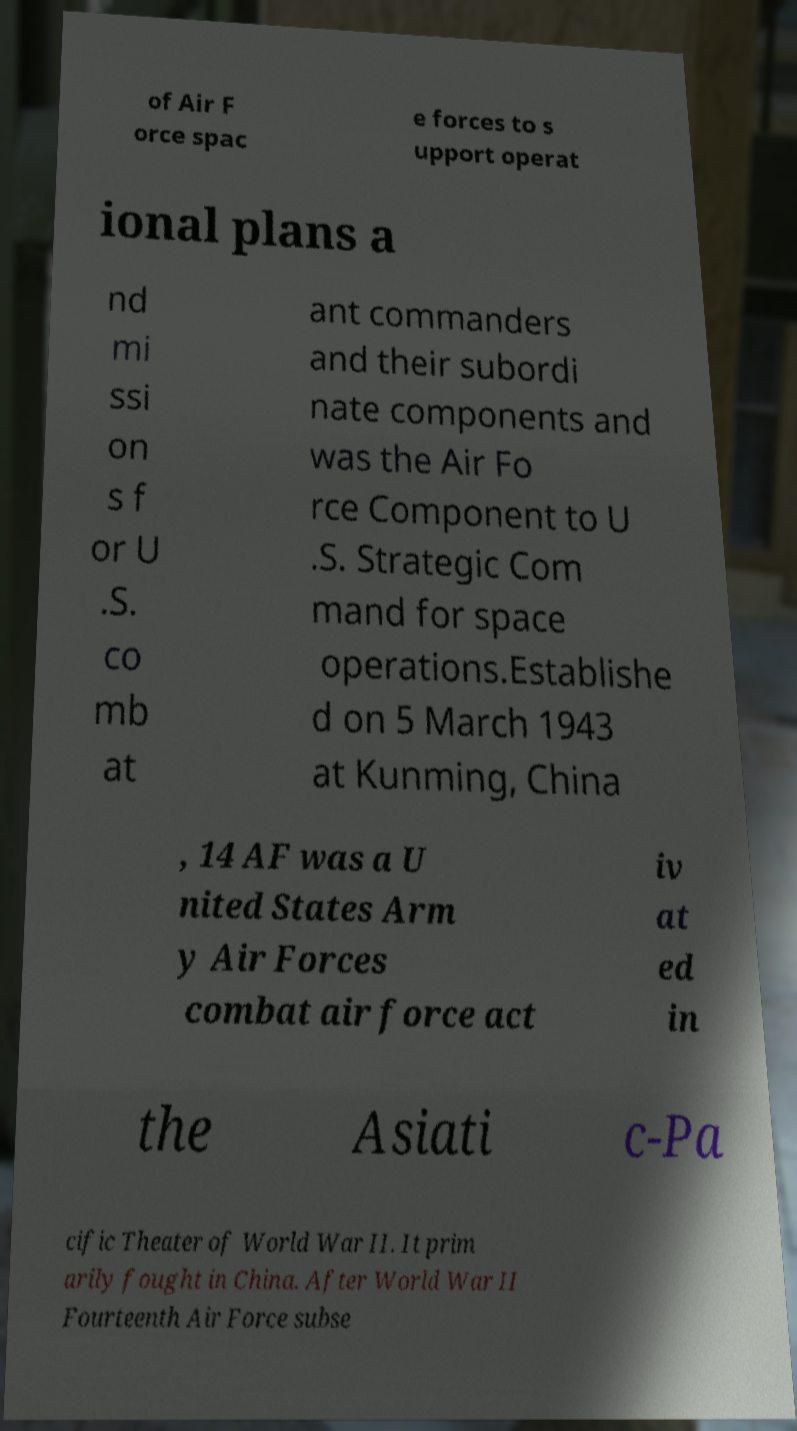Can you read and provide the text displayed in the image?This photo seems to have some interesting text. Can you extract and type it out for me? of Air F orce spac e forces to s upport operat ional plans a nd mi ssi on s f or U .S. co mb at ant commanders and their subordi nate components and was the Air Fo rce Component to U .S. Strategic Com mand for space operations.Establishe d on 5 March 1943 at Kunming, China , 14 AF was a U nited States Arm y Air Forces combat air force act iv at ed in the Asiati c-Pa cific Theater of World War II. It prim arily fought in China. After World War II Fourteenth Air Force subse 